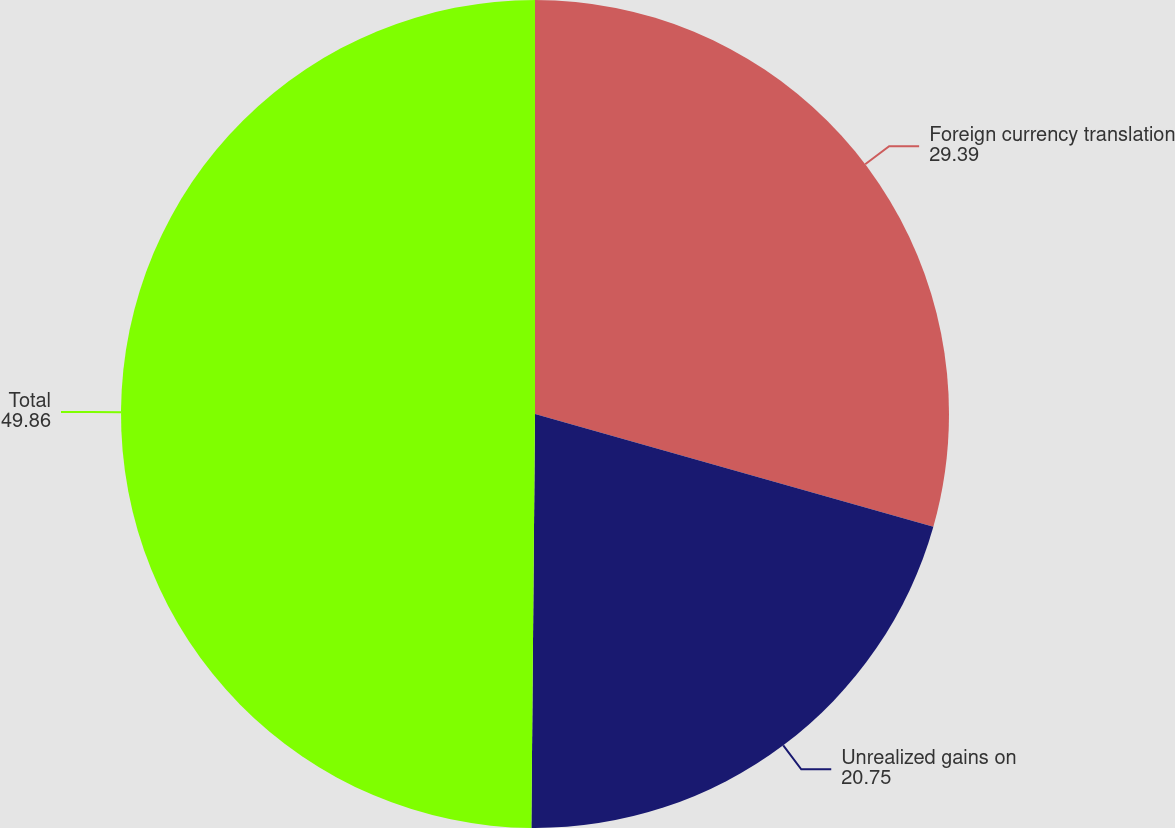Convert chart to OTSL. <chart><loc_0><loc_0><loc_500><loc_500><pie_chart><fcel>Foreign currency translation<fcel>Unrealized gains on<fcel>Total<nl><fcel>29.39%<fcel>20.75%<fcel>49.86%<nl></chart> 